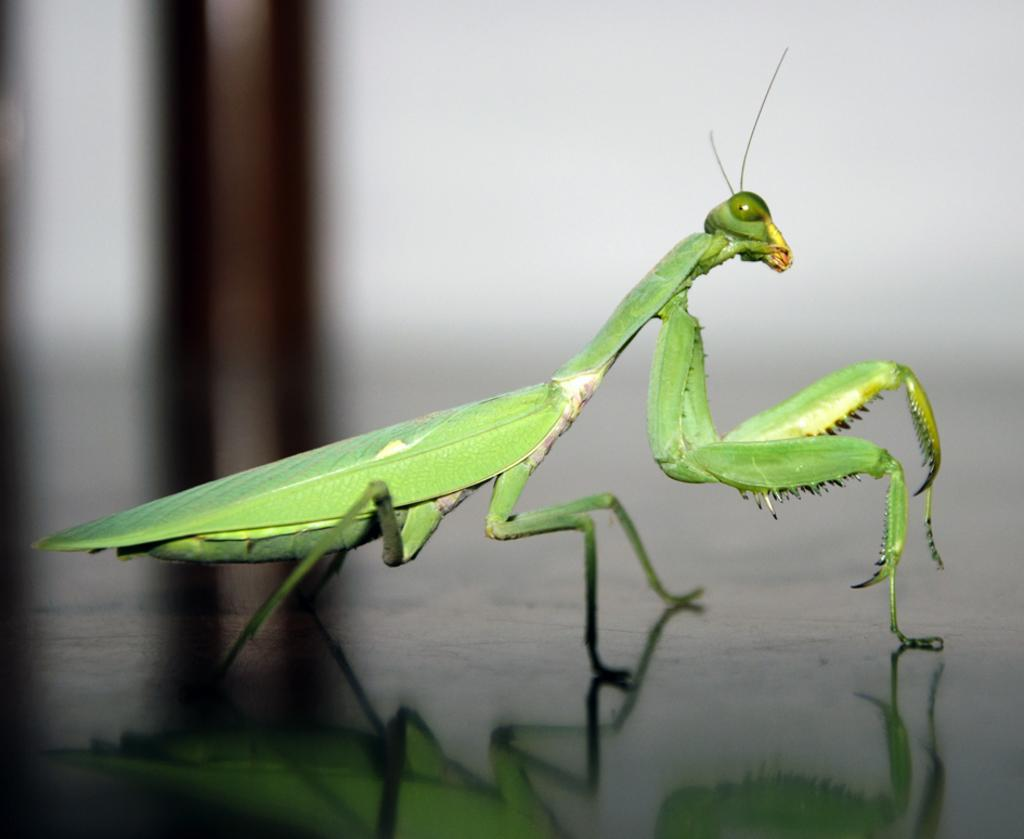What is the main subject of the image? There is a grasshopper in the image. What type of surface is visible in the image? There is a floor in the image. Can you describe the background of the image? The background of the image is blurry. What type of rail can be seen in the image? There is no rail present in the image; it features a grasshopper and a blurry background. Can you tell me the name of the lawyer who made the statement in the image? There is no lawyer or statement present in the image; it only contains a grasshopper and a blurry background. 